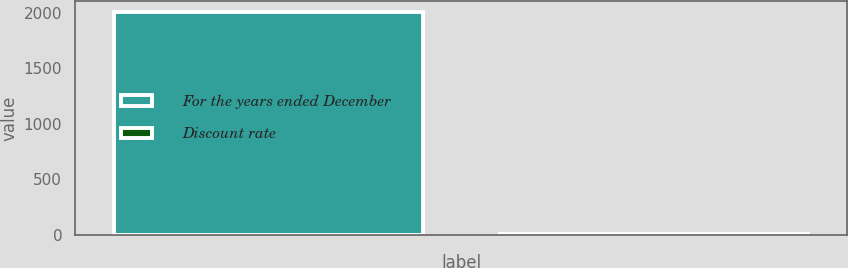Convert chart to OTSL. <chart><loc_0><loc_0><loc_500><loc_500><bar_chart><fcel>For the years ended December<fcel>Discount rate<nl><fcel>2005<fcel>5.7<nl></chart> 